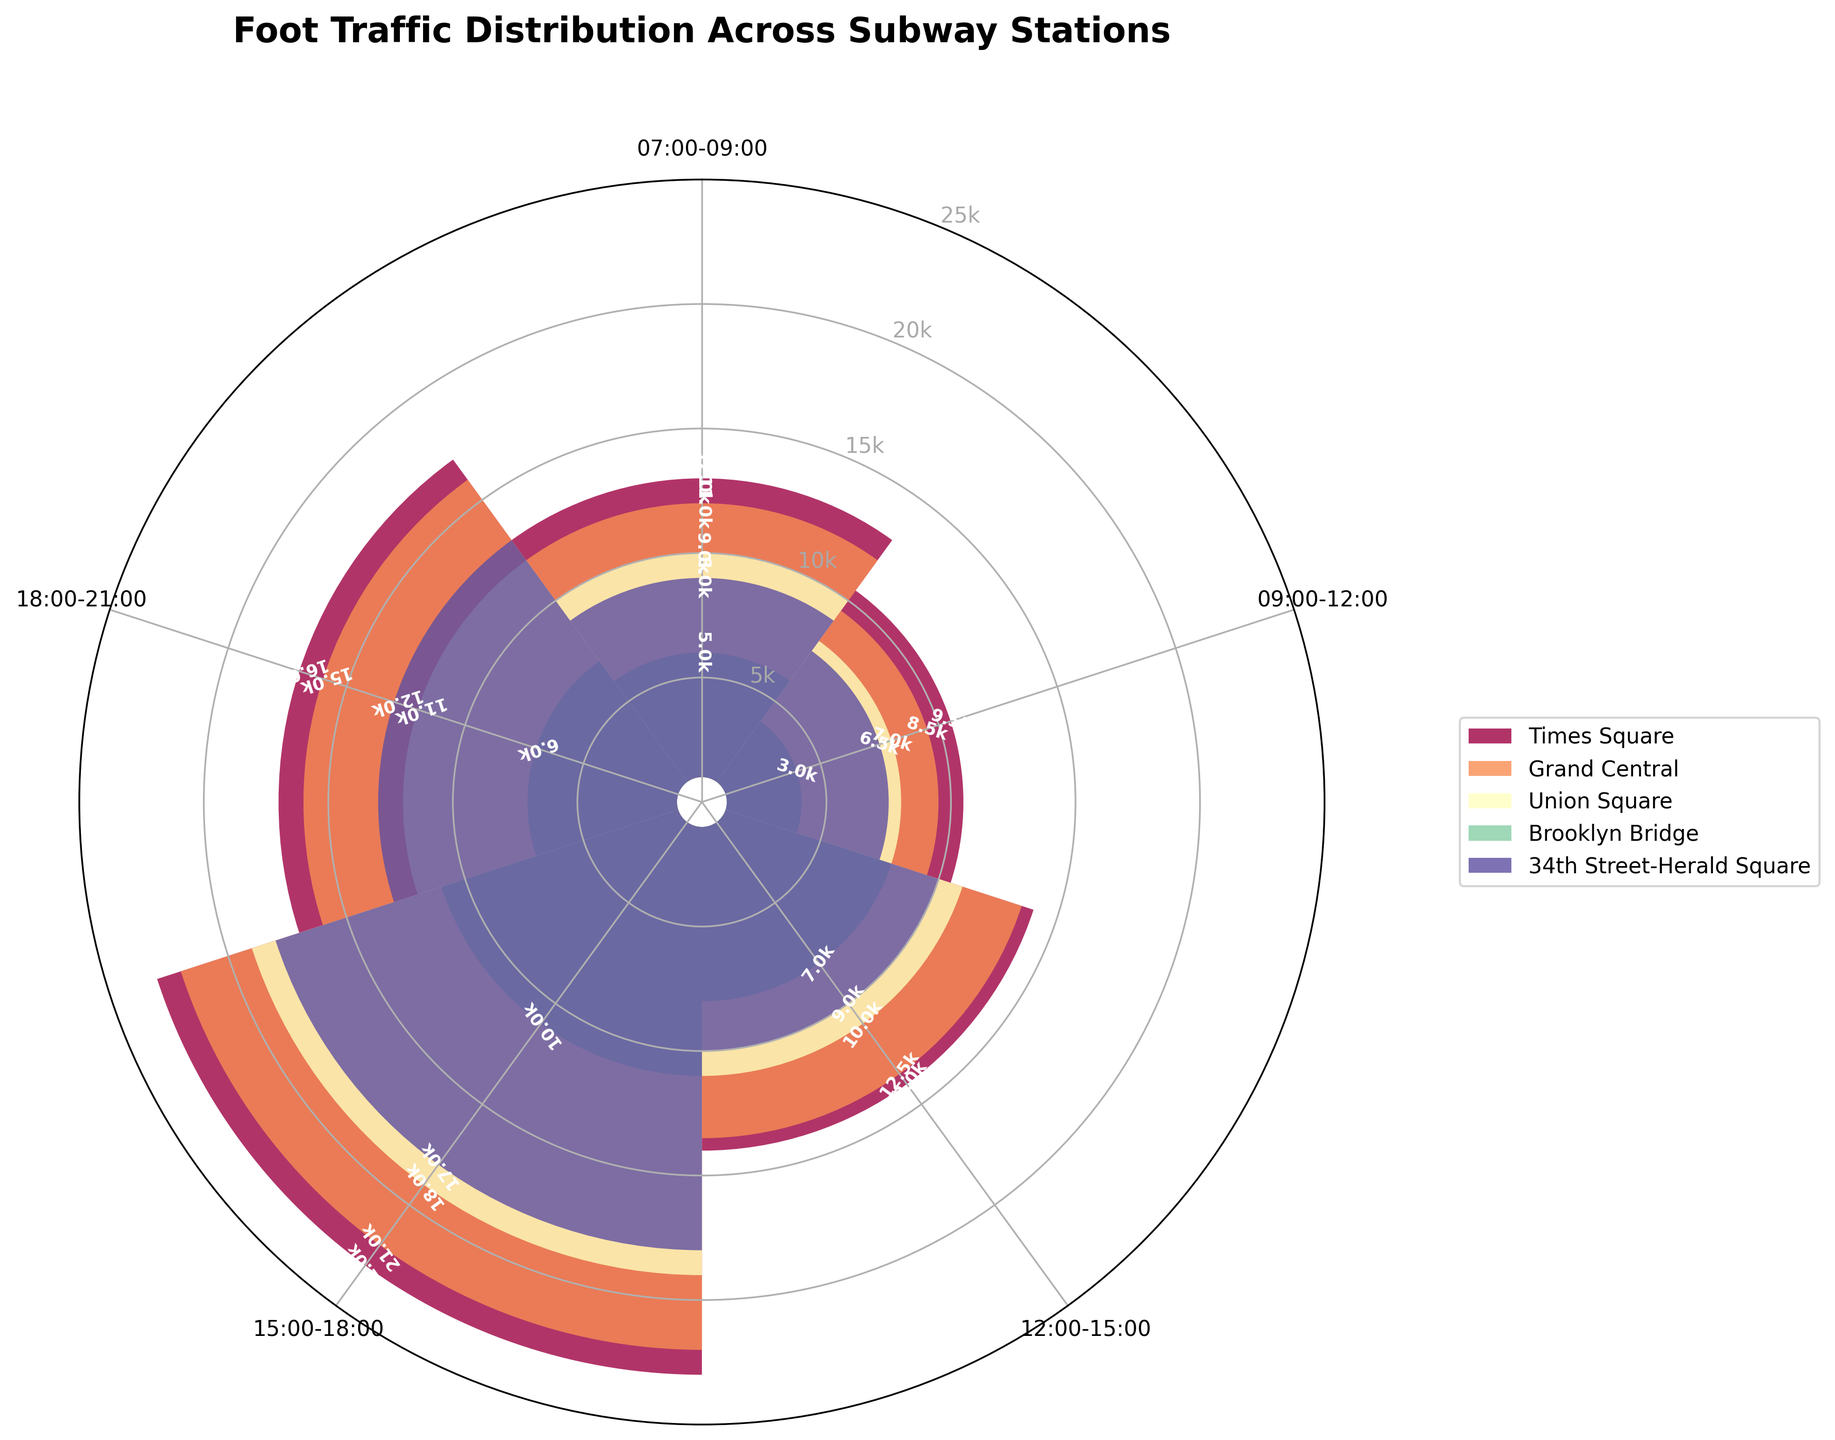What's the title of the figure? The title is located at the top of the figure. It reads "Foot Traffic Distribution Across Subway Stations".
Answer: Foot Traffic Distribution Across Subway Stations How many different subway stations are shown on the plot? The legend on the right side of the figure shows each subway station with different colors. There are 5 different stations listed there.
Answer: 5 Which station has the highest foot traffic between 3 PM and 6 PM? Refer to the section labeled "15:00-18:00" on the plot and compare the bars for each station. The tallest bar corresponds to Times Square.
Answer: Times Square What is the foot traffic at Grand Central between 7 AM and 9 AM? Refer to the segment labeled "07:00-09:00" and look at the bar colored for Grand Central. It shows 11k.
Answer: 11k Which station has the lowest foot traffic in the "18:00-21:00" time range? Look at the section "18:00-21:00" and compare the bars for each station. Brooklyn Bridge has the shortest bar.
Answer: Brooklyn Bridge What is the total foot traffic at Times Square from 3 PM to 9 PM? Locate the segments "15:00-18:00" and "18:00-21:00" for Times Square. The heights show 22k and 16k, respectively. Sum these values (22k + 16k = 38k).
Answer: 38k How does foot traffic at Union Square between 9 AM and 12 PM compare to 12 PM and 3 PM? Locate segments "09:00-12:00" and "12:00-15:00" for Union Square. The heights show 7k and 10k, respectively. 7k is less than 10k.
Answer: Less What is the average foot traffic at Brooklyn Bridge across all time ranges shown? Brooklyn Bridge foot traffic values: 5k, 3k, 7k, 10k, 6k. Calculate the average: (5k + 3k + 7k + 10k + 6k) / 5 = 31k / 5 = 6.2k
Answer: 6.2k Which station has the most similar foot traffic distribution to 34th Street-Herald Square? Visually compare the patterned bars of 34th Street-Herald Square and other stations. Times Square shows the most similar pattern, particularly in peak times.
Answer: Times Square 